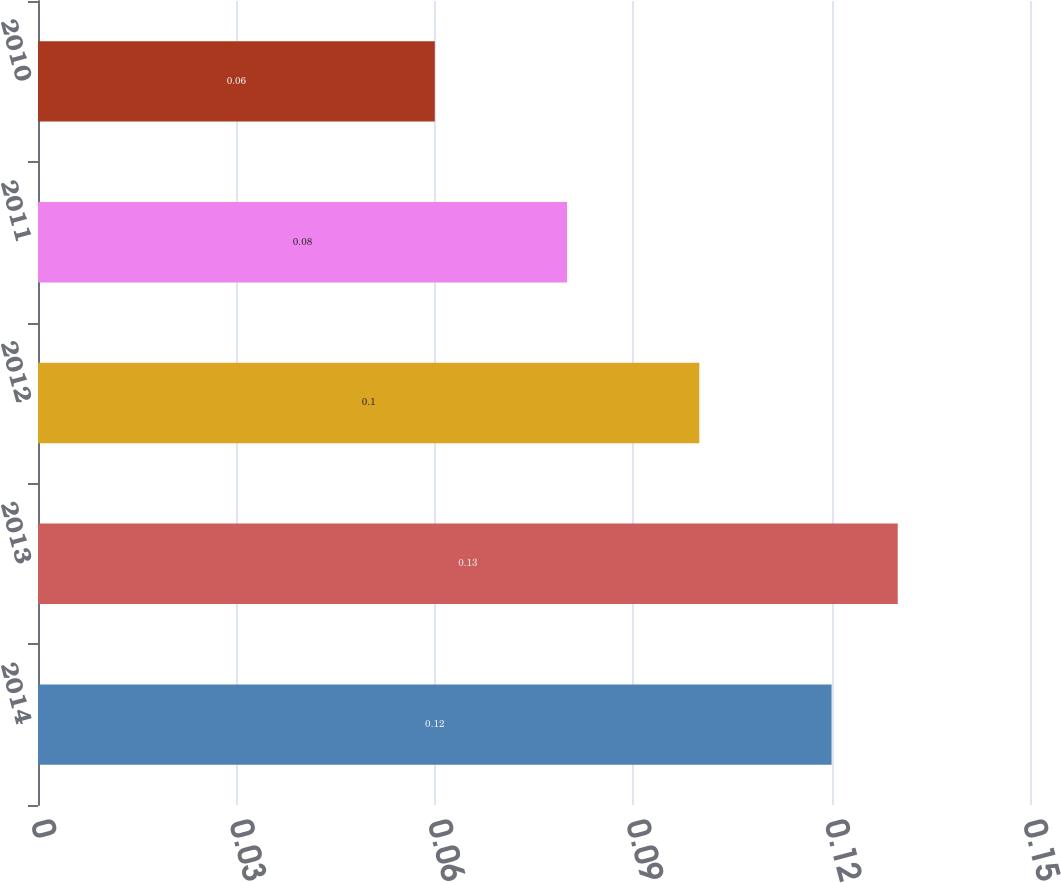Convert chart to OTSL. <chart><loc_0><loc_0><loc_500><loc_500><bar_chart><fcel>2014<fcel>2013<fcel>2012<fcel>2011<fcel>2010<nl><fcel>0.12<fcel>0.13<fcel>0.1<fcel>0.08<fcel>0.06<nl></chart> 